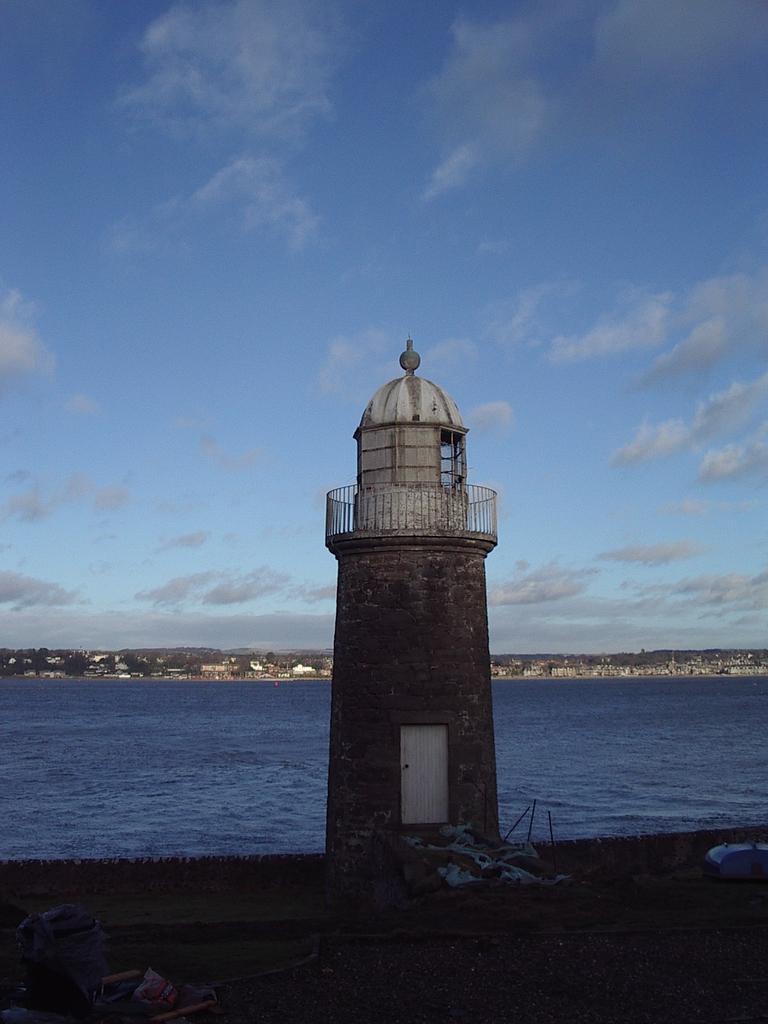In one or two sentences, can you explain what this image depicts? In this image, we can see a lighthouse, door, railing and walls. At the bottom of the image, we can see few objects. Background we can see the water, houses, trees and sky. 